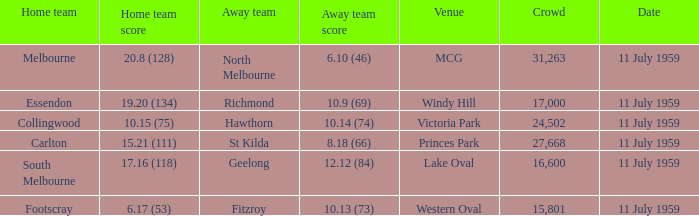How many points does footscray earn as the home squad? 6.17 (53). 